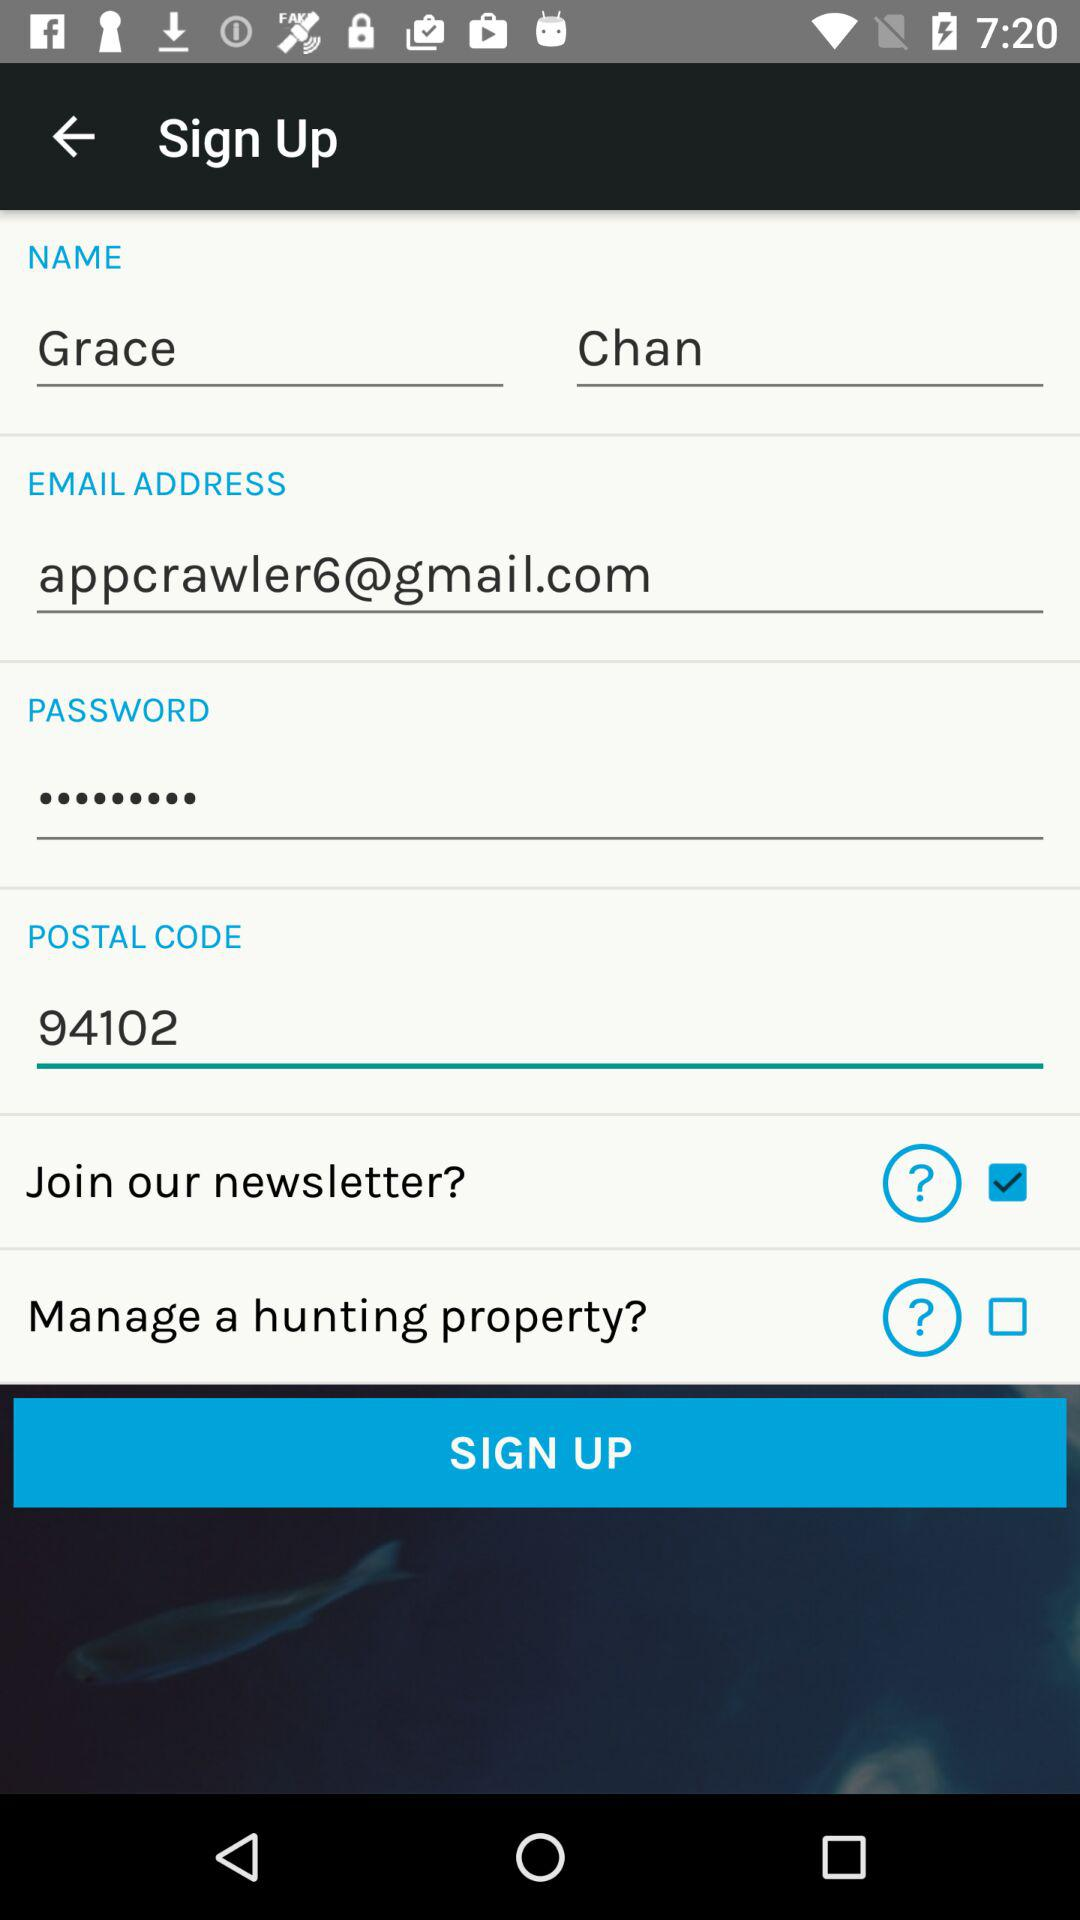How many check boxes are there on the sign up form?
Answer the question using a single word or phrase. 2 